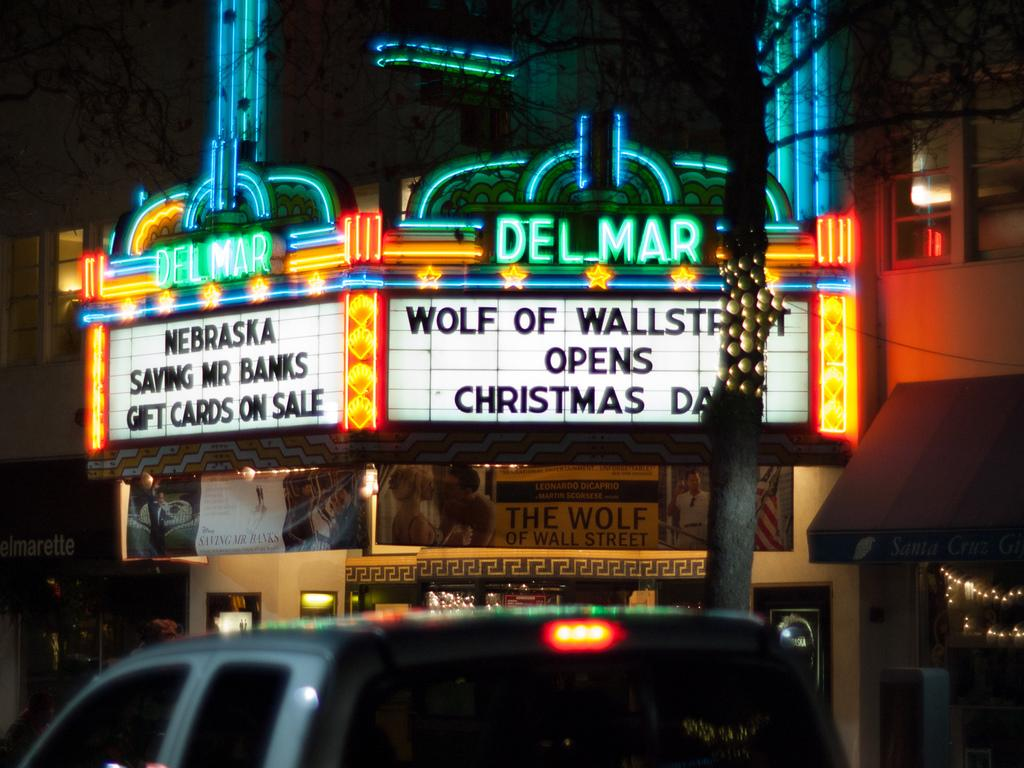<image>
Give a short and clear explanation of the subsequent image. Two movies are playing at the Del Mar theatre, and another opens on Christmas. 